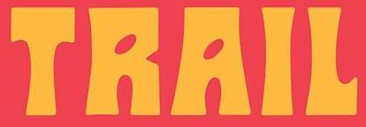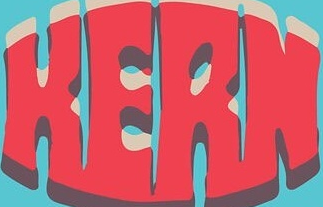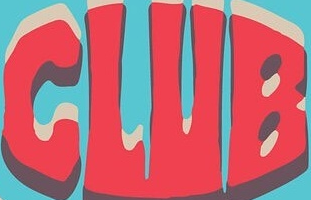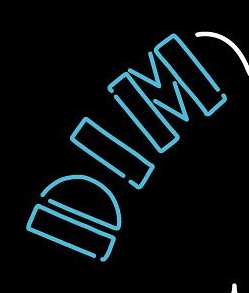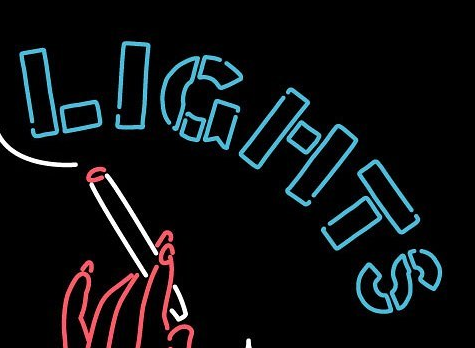Read the text from these images in sequence, separated by a semicolon. TRAIL; HERN; CLUB; DIM; LIGHTS 